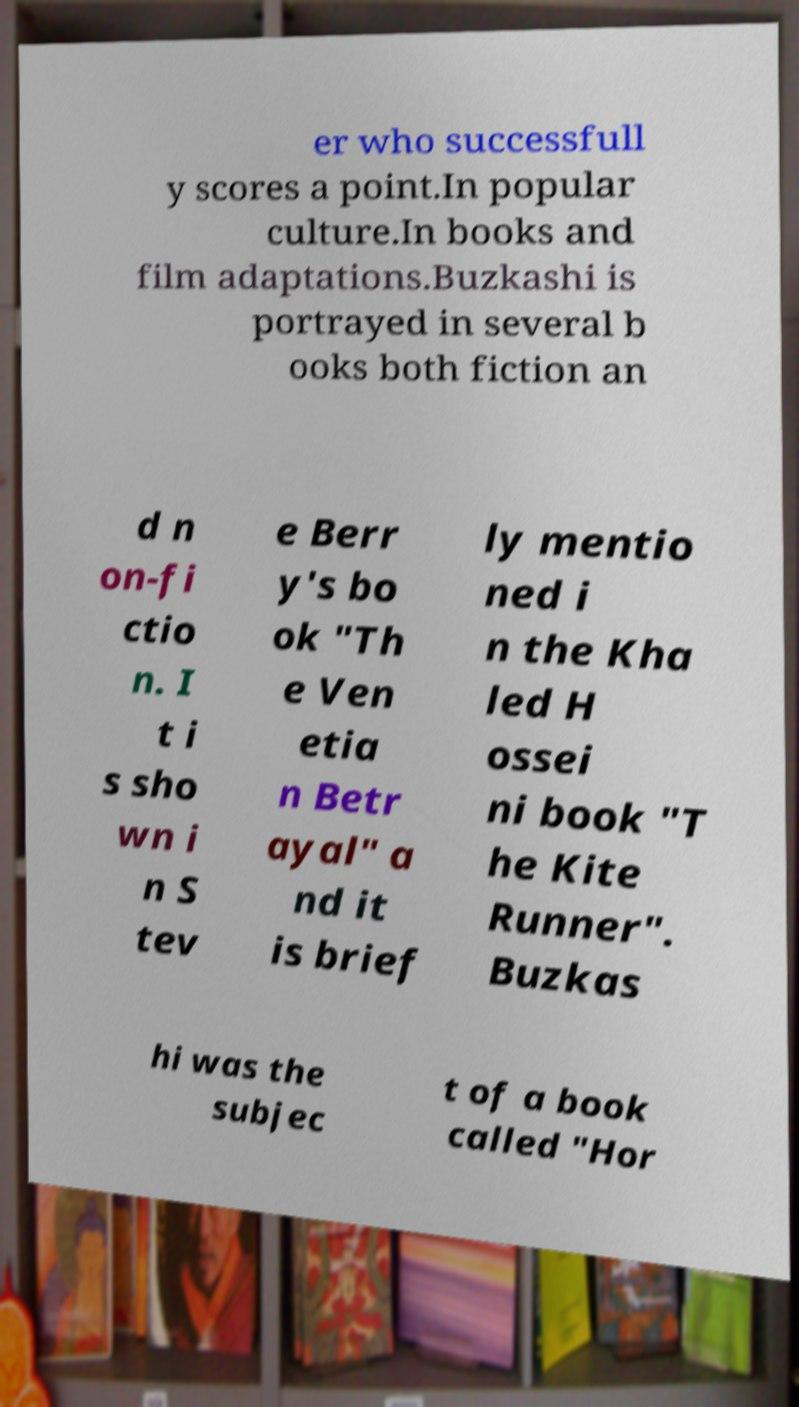Please read and relay the text visible in this image. What does it say? er who successfull y scores a point.In popular culture.In books and film adaptations.Buzkashi is portrayed in several b ooks both fiction an d n on-fi ctio n. I t i s sho wn i n S tev e Berr y's bo ok "Th e Ven etia n Betr ayal" a nd it is brief ly mentio ned i n the Kha led H ossei ni book "T he Kite Runner". Buzkas hi was the subjec t of a book called "Hor 